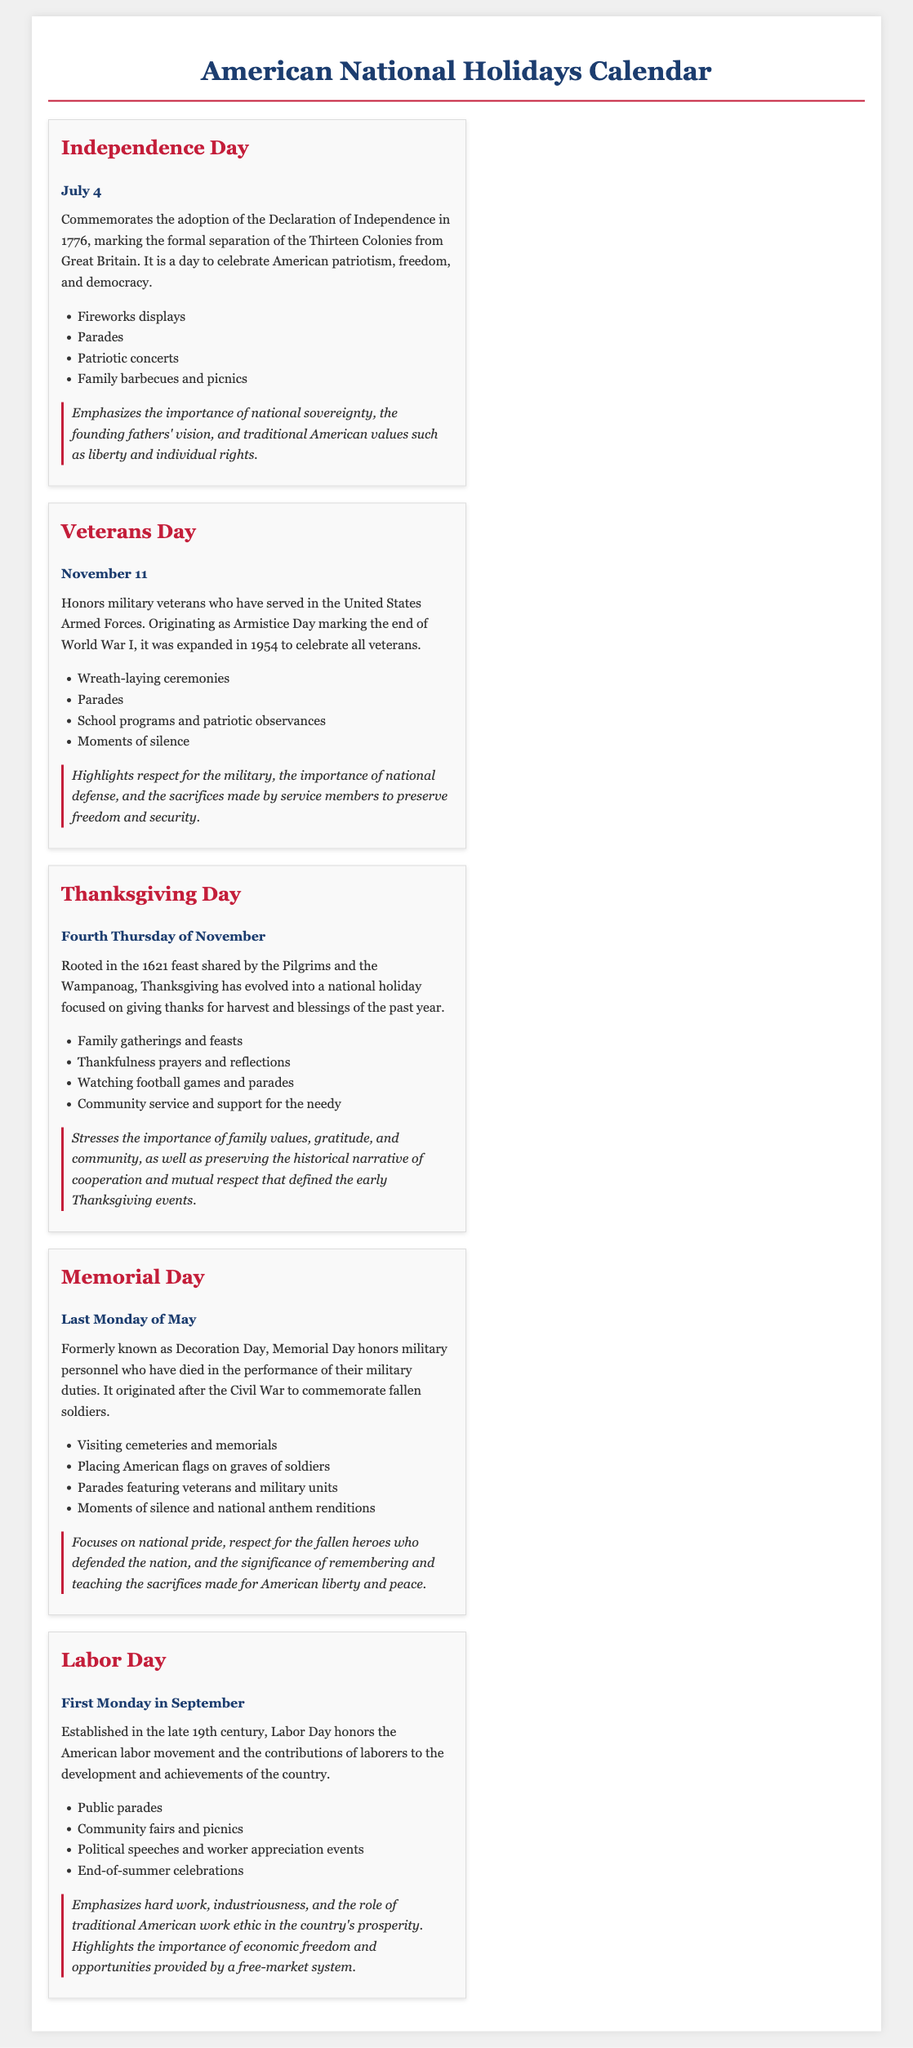what day is Independence Day celebrated? Independence Day is celebrated on July 4, as stated in the document.
Answer: July 4 what is the historical significance of Veterans Day? Veterans Day honors military veterans and originated as Armistice Day marking the end of World War I.
Answer: Honors military veterans what traditional activity is associated with Thanksgiving Day? The document lists family gatherings and feasts as a traditional activity associated with Thanksgiving Day.
Answer: Family gatherings and feasts when is Memorial Day observed? Memorial Day is observed on the last Monday of May, as indicated in the document.
Answer: Last Monday of May what does Labor Day honor? Labor Day honors the American labor movement and contributions of laborers to the nation, as stated.
Answer: American labor movement what is emphasized in the conservative view of Independence Day? The conservative view emphasizes the importance of national sovereignty and traditional American values.
Answer: National sovereignty how did Memorial Day originate? Memorial Day originated after the Civil War to commemorate fallen soldiers.
Answer: After the Civil War what type of events are common during Labor Day? The document describes public parades and community fairs as common events during Labor Day.
Answer: Public parades and community fairs 